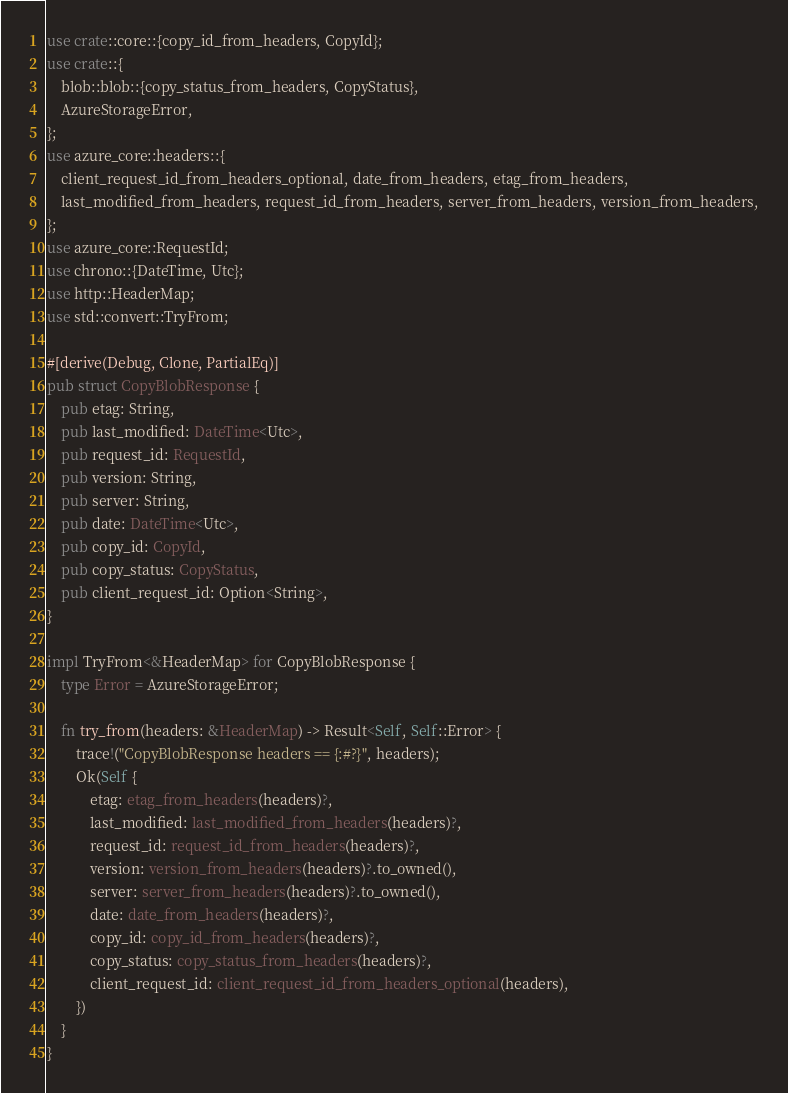Convert code to text. <code><loc_0><loc_0><loc_500><loc_500><_Rust_>use crate::core::{copy_id_from_headers, CopyId};
use crate::{
    blob::blob::{copy_status_from_headers, CopyStatus},
    AzureStorageError,
};
use azure_core::headers::{
    client_request_id_from_headers_optional, date_from_headers, etag_from_headers,
    last_modified_from_headers, request_id_from_headers, server_from_headers, version_from_headers,
};
use azure_core::RequestId;
use chrono::{DateTime, Utc};
use http::HeaderMap;
use std::convert::TryFrom;

#[derive(Debug, Clone, PartialEq)]
pub struct CopyBlobResponse {
    pub etag: String,
    pub last_modified: DateTime<Utc>,
    pub request_id: RequestId,
    pub version: String,
    pub server: String,
    pub date: DateTime<Utc>,
    pub copy_id: CopyId,
    pub copy_status: CopyStatus,
    pub client_request_id: Option<String>,
}

impl TryFrom<&HeaderMap> for CopyBlobResponse {
    type Error = AzureStorageError;

    fn try_from(headers: &HeaderMap) -> Result<Self, Self::Error> {
        trace!("CopyBlobResponse headers == {:#?}", headers);
        Ok(Self {
            etag: etag_from_headers(headers)?,
            last_modified: last_modified_from_headers(headers)?,
            request_id: request_id_from_headers(headers)?,
            version: version_from_headers(headers)?.to_owned(),
            server: server_from_headers(headers)?.to_owned(),
            date: date_from_headers(headers)?,
            copy_id: copy_id_from_headers(headers)?,
            copy_status: copy_status_from_headers(headers)?,
            client_request_id: client_request_id_from_headers_optional(headers),
        })
    }
}
</code> 